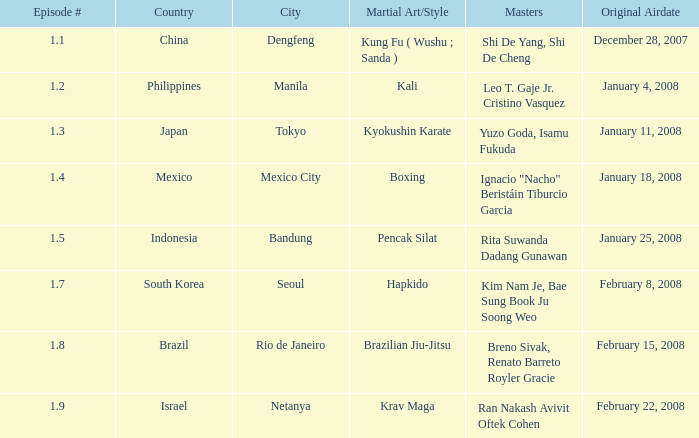In which country is the city of Netanya? Israel. 